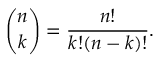<formula> <loc_0><loc_0><loc_500><loc_500>{ \binom { n } { k } } = { \frac { n ! } { k ! ( n - k ) ! } } .</formula> 